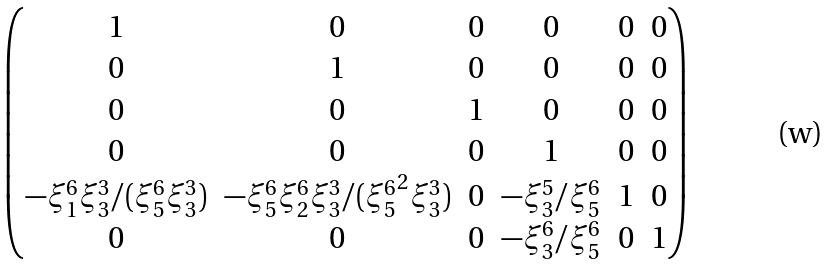<formula> <loc_0><loc_0><loc_500><loc_500>\begin{pmatrix} 1 & 0 & 0 & 0 & 0 & 0 \\ 0 & 1 & 0 & 0 & 0 & 0 \\ 0 & 0 & 1 & 0 & 0 & 0 \\ 0 & 0 & 0 & 1 & 0 & 0 \\ - { \xi ^ { 6 } _ { 1 } } { \xi ^ { 3 } _ { 3 } } / ( { \xi ^ { 6 } _ { 5 } } { \xi ^ { 3 } _ { 3 } } ) & - { \xi ^ { 6 } _ { 5 } } { \xi ^ { 6 } _ { 2 } } { \xi ^ { 3 } _ { 3 } } / ( { \xi ^ { 6 } _ { 5 } } ^ { 2 } { \xi ^ { 3 } _ { 3 } } ) & 0 & - { \xi ^ { 5 } _ { 3 } } / { \xi ^ { 6 } _ { 5 } } & 1 & 0 \\ 0 & 0 & 0 & - { \xi ^ { 6 } _ { 3 } } / { \xi ^ { 6 } _ { 5 } } & 0 & 1 \end{pmatrix}</formula> 